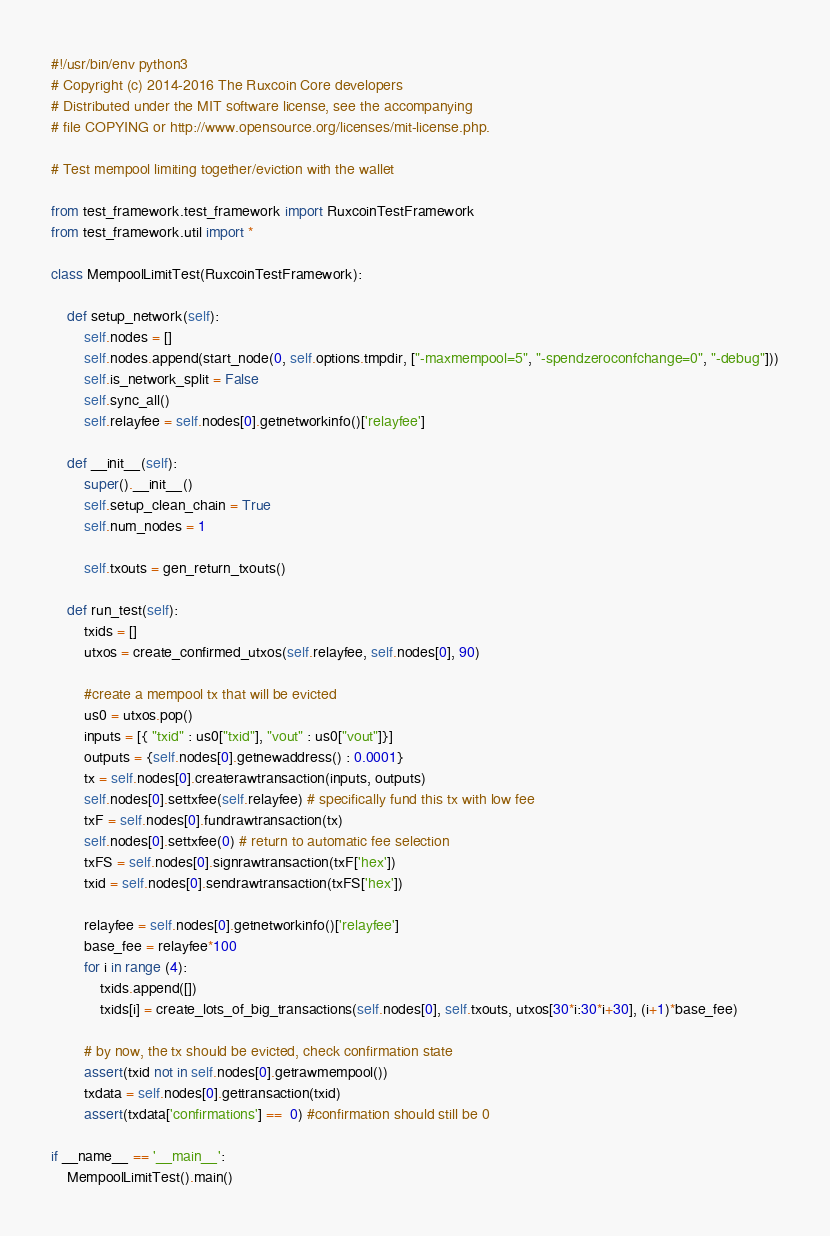<code> <loc_0><loc_0><loc_500><loc_500><_Python_>#!/usr/bin/env python3
# Copyright (c) 2014-2016 The Ruxcoin Core developers
# Distributed under the MIT software license, see the accompanying
# file COPYING or http://www.opensource.org/licenses/mit-license.php.

# Test mempool limiting together/eviction with the wallet

from test_framework.test_framework import RuxcoinTestFramework
from test_framework.util import *

class MempoolLimitTest(RuxcoinTestFramework):

    def setup_network(self):
        self.nodes = []
        self.nodes.append(start_node(0, self.options.tmpdir, ["-maxmempool=5", "-spendzeroconfchange=0", "-debug"]))
        self.is_network_split = False
        self.sync_all()
        self.relayfee = self.nodes[0].getnetworkinfo()['relayfee']

    def __init__(self):
        super().__init__()
        self.setup_clean_chain = True
        self.num_nodes = 1

        self.txouts = gen_return_txouts()

    def run_test(self):
        txids = []
        utxos = create_confirmed_utxos(self.relayfee, self.nodes[0], 90)

        #create a mempool tx that will be evicted
        us0 = utxos.pop()
        inputs = [{ "txid" : us0["txid"], "vout" : us0["vout"]}]
        outputs = {self.nodes[0].getnewaddress() : 0.0001}
        tx = self.nodes[0].createrawtransaction(inputs, outputs)
        self.nodes[0].settxfee(self.relayfee) # specifically fund this tx with low fee
        txF = self.nodes[0].fundrawtransaction(tx)
        self.nodes[0].settxfee(0) # return to automatic fee selection
        txFS = self.nodes[0].signrawtransaction(txF['hex'])
        txid = self.nodes[0].sendrawtransaction(txFS['hex'])

        relayfee = self.nodes[0].getnetworkinfo()['relayfee']
        base_fee = relayfee*100
        for i in range (4):
            txids.append([])
            txids[i] = create_lots_of_big_transactions(self.nodes[0], self.txouts, utxos[30*i:30*i+30], (i+1)*base_fee)

        # by now, the tx should be evicted, check confirmation state
        assert(txid not in self.nodes[0].getrawmempool())
        txdata = self.nodes[0].gettransaction(txid)
        assert(txdata['confirmations'] ==  0) #confirmation should still be 0

if __name__ == '__main__':
    MempoolLimitTest().main()
</code> 